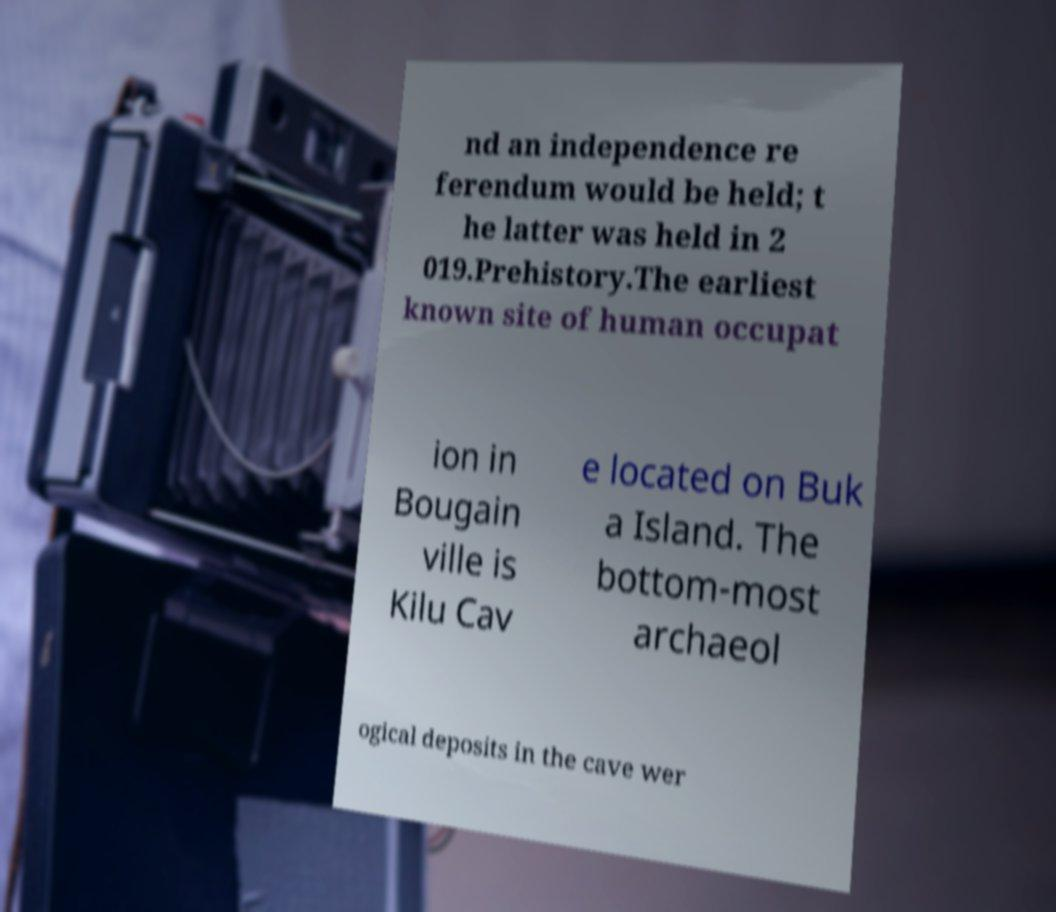I need the written content from this picture converted into text. Can you do that? nd an independence re ferendum would be held; t he latter was held in 2 019.Prehistory.The earliest known site of human occupat ion in Bougain ville is Kilu Cav e located on Buk a Island. The bottom-most archaeol ogical deposits in the cave wer 